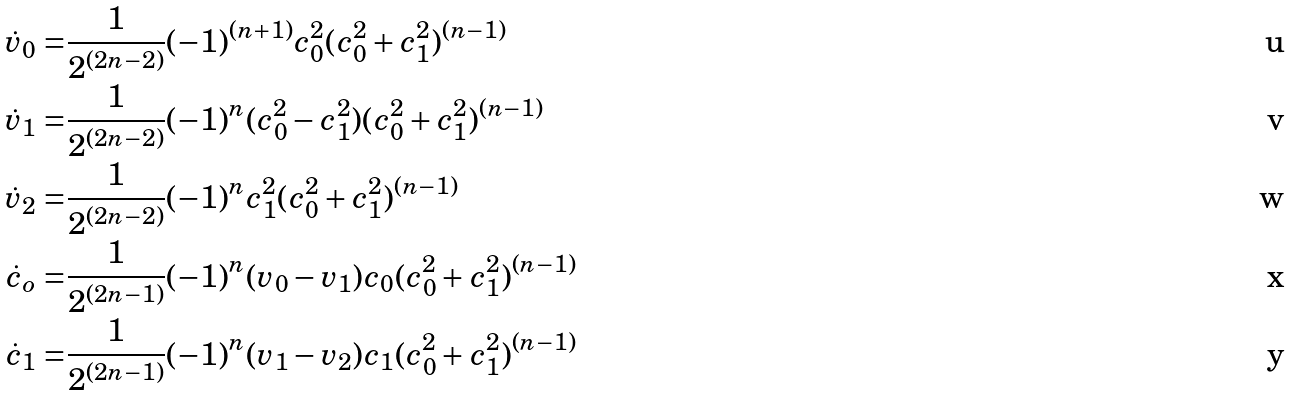Convert formula to latex. <formula><loc_0><loc_0><loc_500><loc_500>\dot { v } _ { 0 } = & \frac { 1 } { 2 ^ { ( 2 n - 2 ) } } ( - 1 ) ^ { ( n + 1 ) } c _ { 0 } ^ { 2 } ( c _ { 0 } ^ { 2 } + c _ { 1 } ^ { 2 } ) ^ { ( n - 1 ) } \\ \dot { v } _ { 1 } = & \frac { 1 } { 2 ^ { ( 2 n - 2 ) } } ( - 1 ) ^ { n } ( c _ { 0 } ^ { 2 } - c _ { 1 } ^ { 2 } ) ( c _ { 0 } ^ { 2 } + c _ { 1 } ^ { 2 } ) ^ { ( n - 1 ) } \\ \dot { v } _ { 2 } = & \frac { 1 } { 2 ^ { ( 2 n - 2 ) } } ( - 1 ) ^ { n } c _ { 1 } ^ { 2 } ( c _ { 0 } ^ { 2 } + c _ { 1 } ^ { 2 } ) ^ { ( n - 1 ) } \\ \dot { c } _ { o } = & \frac { 1 } { 2 ^ { ( 2 n - 1 ) } } ( - 1 ) ^ { n } ( v _ { 0 } - v _ { 1 } ) c _ { 0 } ( c _ { 0 } ^ { 2 } + c _ { 1 } ^ { 2 } ) ^ { ( n - 1 ) } \\ \dot { c } _ { 1 } = & \frac { 1 } { 2 ^ { ( 2 n - 1 ) } } ( - 1 ) ^ { n } ( v _ { 1 } - v _ { 2 } ) c _ { 1 } ( c _ { 0 } ^ { 2 } + c _ { 1 } ^ { 2 } ) ^ { ( n - 1 ) }</formula> 